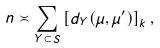<formula> <loc_0><loc_0><loc_500><loc_500>n \asymp \sum _ { Y \subset S } \left [ d _ { Y } ( \mu , \mu ^ { \prime } ) \right ] _ { k } ,</formula> 